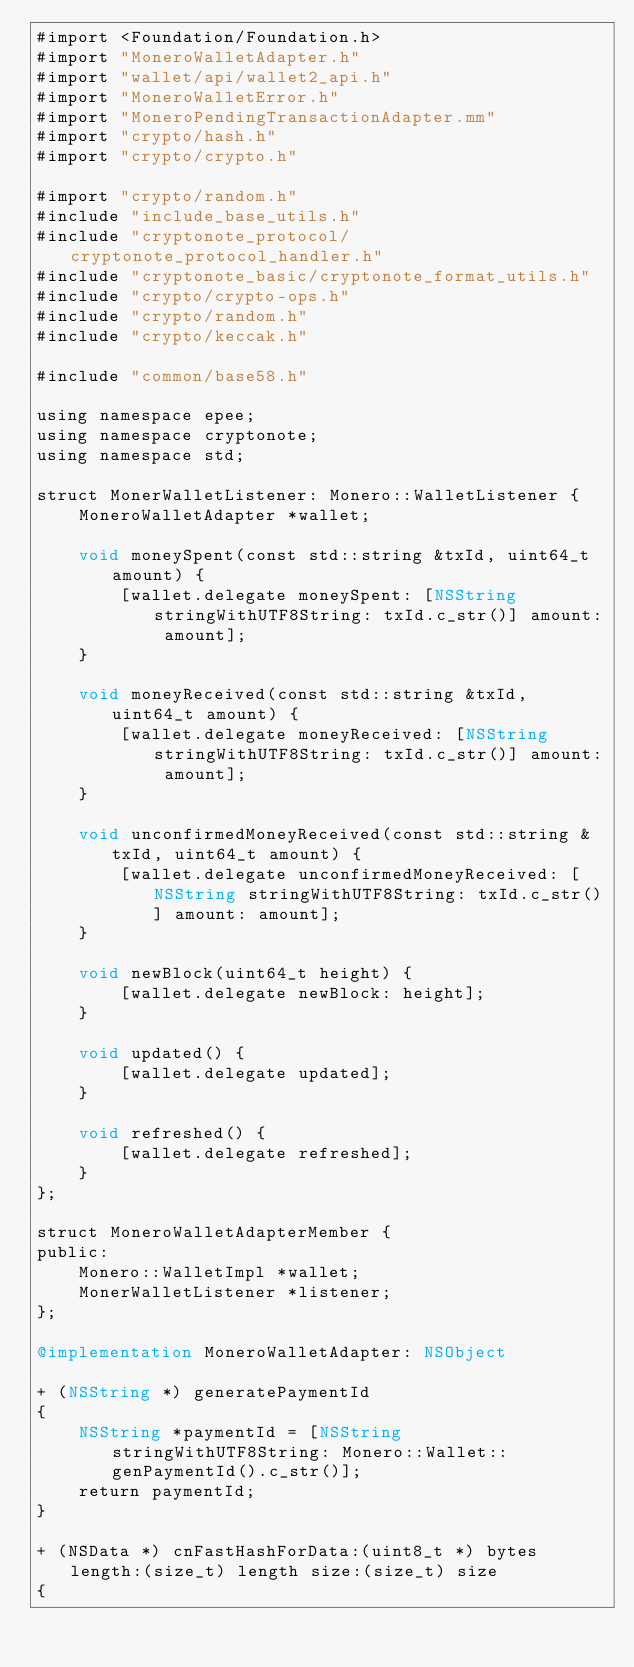Convert code to text. <code><loc_0><loc_0><loc_500><loc_500><_ObjectiveC_>#import <Foundation/Foundation.h>
#import "MoneroWalletAdapter.h"
#import "wallet/api/wallet2_api.h"
#import "MoneroWalletError.h"
#import "MoneroPendingTransactionAdapter.mm"
#import "crypto/hash.h"
#import "crypto/crypto.h"

#import "crypto/random.h"
#include "include_base_utils.h"
#include "cryptonote_protocol/cryptonote_protocol_handler.h"
#include "cryptonote_basic/cryptonote_format_utils.h"
#include "crypto/crypto-ops.h"
#include "crypto/random.h"
#include "crypto/keccak.h"

#include "common/base58.h"

using namespace epee;
using namespace cryptonote;
using namespace std;

struct MonerWalletListener: Monero::WalletListener {
    MoneroWalletAdapter *wallet;
    
    void moneySpent(const std::string &txId, uint64_t amount) {
        [wallet.delegate moneySpent: [NSString stringWithUTF8String: txId.c_str()] amount: amount];
    }
    
    void moneyReceived(const std::string &txId, uint64_t amount) {
        [wallet.delegate moneyReceived: [NSString stringWithUTF8String: txId.c_str()] amount: amount];
    }
    
    void unconfirmedMoneyReceived(const std::string &txId, uint64_t amount) {
        [wallet.delegate unconfirmedMoneyReceived: [NSString stringWithUTF8String: txId.c_str()] amount: amount];
    }
    
    void newBlock(uint64_t height) {
        [wallet.delegate newBlock: height];
    }
    
    void updated() {
        [wallet.delegate updated];
    }
    
    void refreshed() {
        [wallet.delegate refreshed];
    }
};

struct MoneroWalletAdapterMember {
public:
    Monero::WalletImpl *wallet;
    MonerWalletListener *listener;
};

@implementation MoneroWalletAdapter: NSObject

+ (NSString *) generatePaymentId
{
    NSString *paymentId = [NSString stringWithUTF8String: Monero::Wallet::genPaymentId().c_str()];
    return paymentId;
}

+ (NSData *) cnFastHashForData:(uint8_t *) bytes length:(size_t) length size:(size_t) size
{</code> 